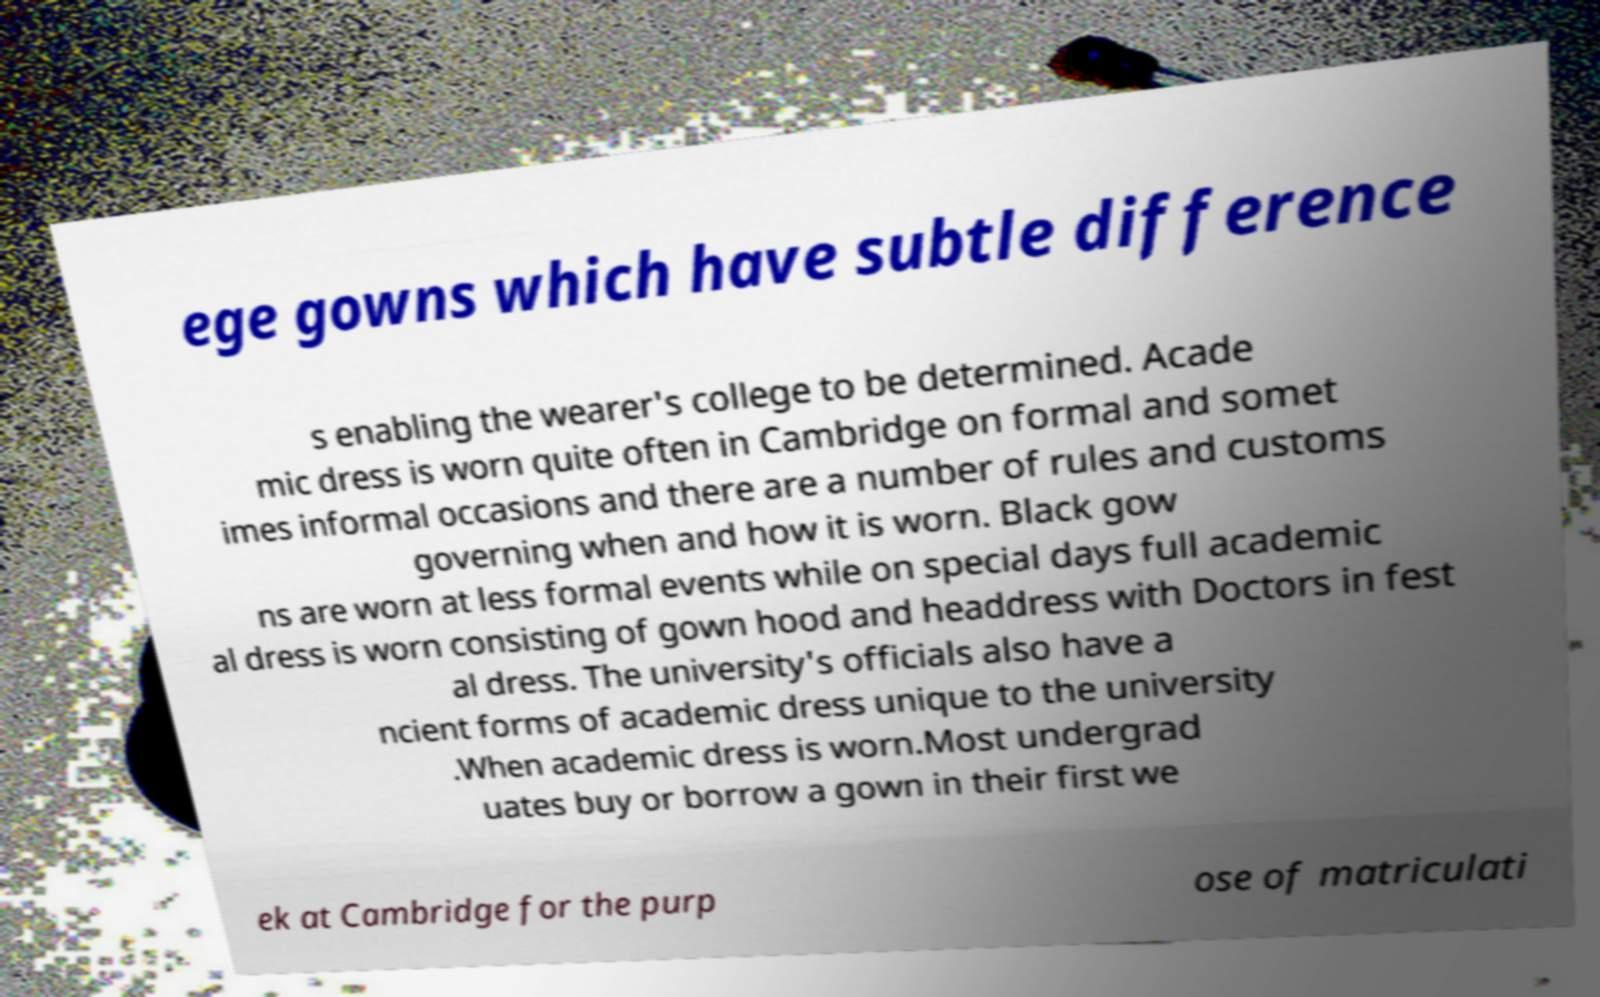Could you extract and type out the text from this image? ege gowns which have subtle difference s enabling the wearer's college to be determined. Acade mic dress is worn quite often in Cambridge on formal and somet imes informal occasions and there are a number of rules and customs governing when and how it is worn. Black gow ns are worn at less formal events while on special days full academic al dress is worn consisting of gown hood and headdress with Doctors in fest al dress. The university's officials also have a ncient forms of academic dress unique to the university .When academic dress is worn.Most undergrad uates buy or borrow a gown in their first we ek at Cambridge for the purp ose of matriculati 